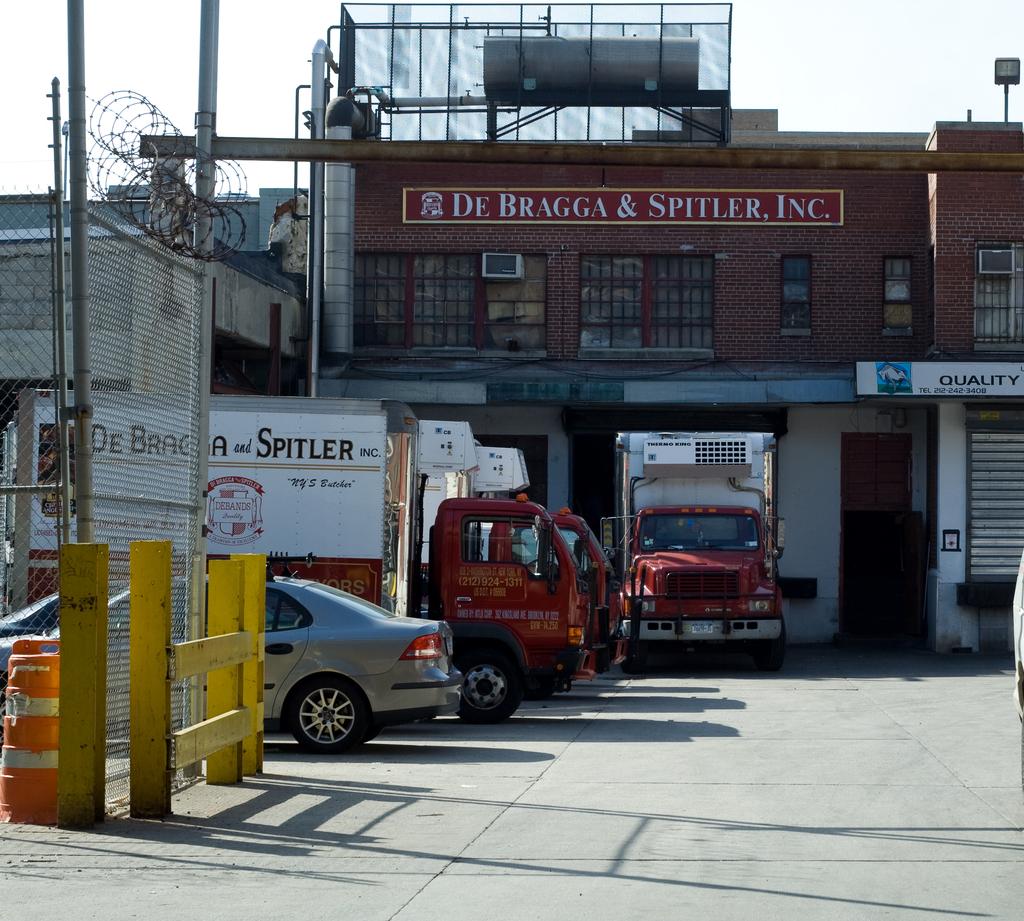What is the name of the company on the top floor?
Provide a short and direct response. De bragga & spitler. What is the phone number on the side of the red truck?
Provide a succinct answer. 212-924-1311. 